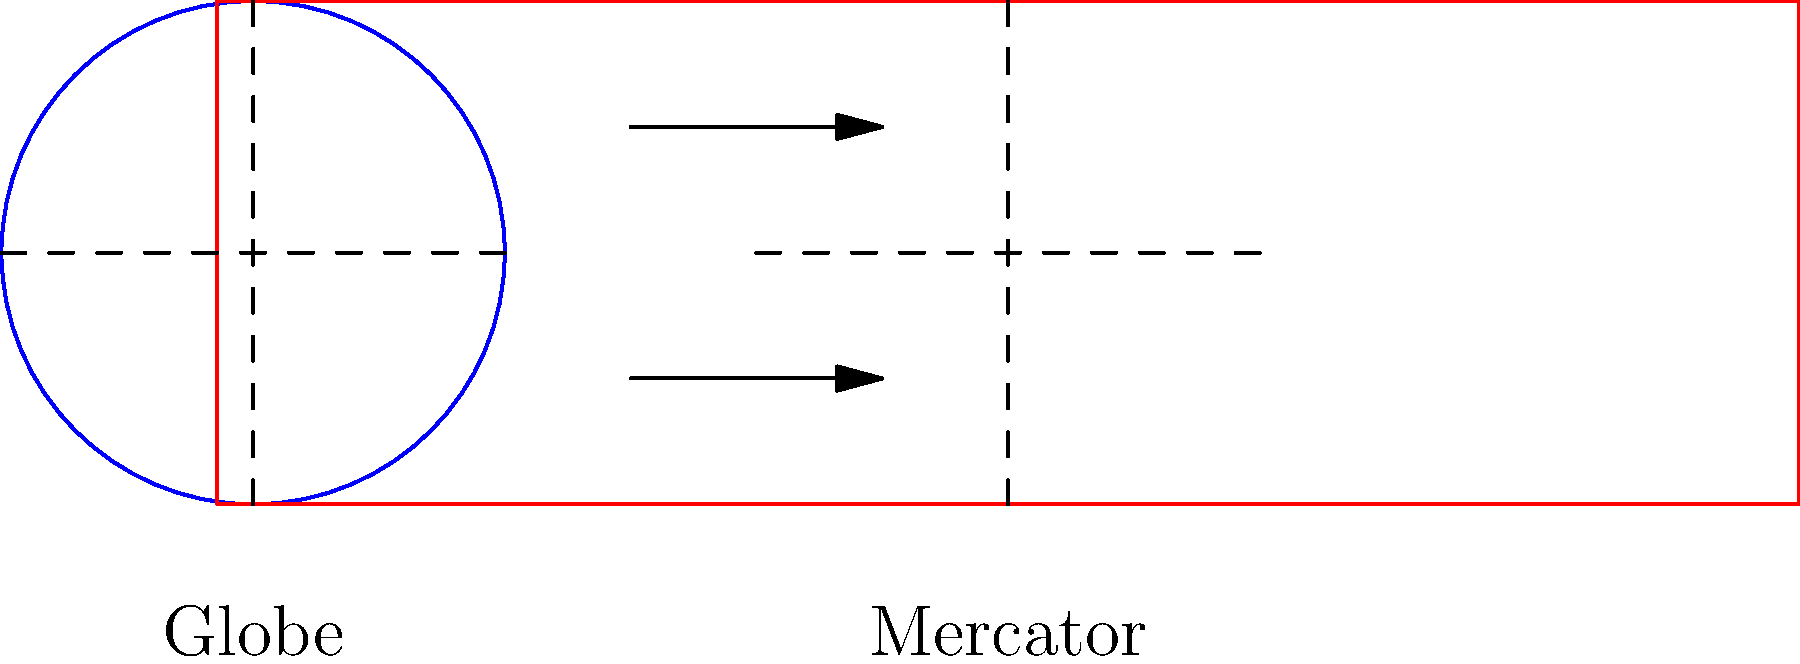Consider the globe and its Mercator projection shown above. Which statement best describes the distortion that occurs in the Mercator projection, particularly in relation to landmasses near the poles? To answer this question, let's analyze the Mercator projection's distortion:

1. The Mercator projection is a cylindrical map projection.

2. On the globe (left), latitude lines are equally spaced.

3. On the Mercator projection (right), we observe:
   a) The spacing between latitude lines increases as we move away from the equator.
   b) This is shown by the expanding vertical space on the red rectangle.

4. This distortion affects landmasses differently:
   a) Areas near the equator are relatively accurately represented.
   b) Areas closer to the poles are significantly stretched vertically.

5. The consequences of this distortion:
   a) Landmasses near the poles appear much larger than they actually are.
   b) For example, Greenland often appears similar in size to Africa on Mercator maps, despite being about 14 times smaller in reality.

6. This distortion can lead to misconceptions about the relative sizes of countries and continents, potentially influencing global perspectives.

7. It's crucial to remember that all map projections involve some form of distortion, as it's impossible to perfectly represent a spherical surface on a flat plane.

The Mercator projection's distortion exemplifies how cartographic choices can inadvertently shape our understanding of global geography and potentially influence geopolitical perceptions.
Answer: Landmasses near poles appear disproportionately larger than their actual size. 